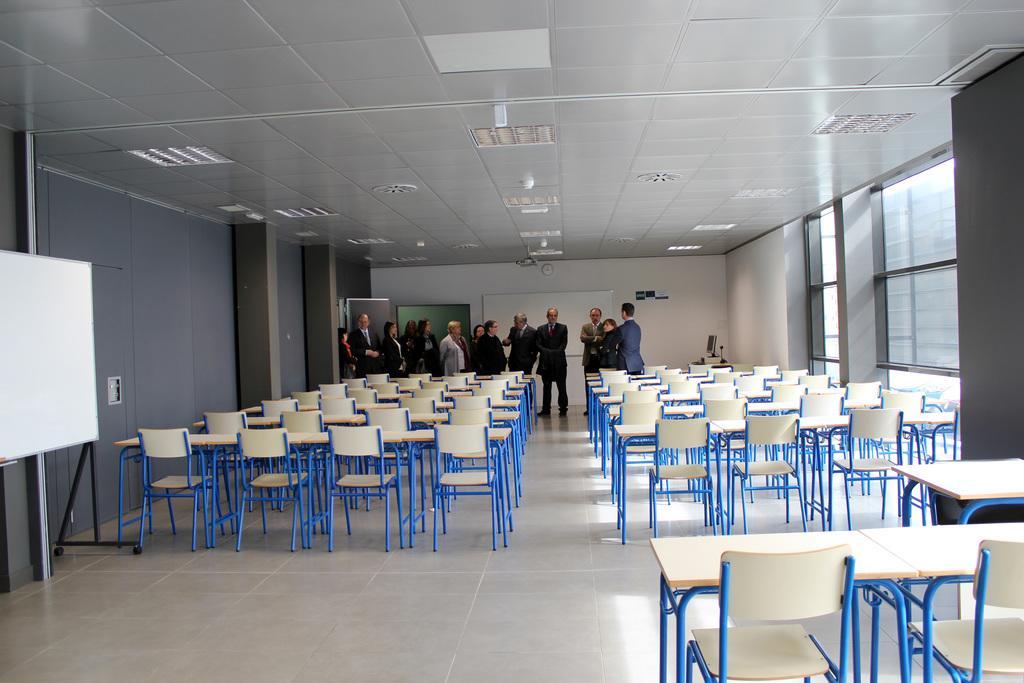Please provide a concise description of this image. Here we can see few persons are standing on the floor. There are chairs, boards, and lights. This is wall and there are pillars. And this is roof. 